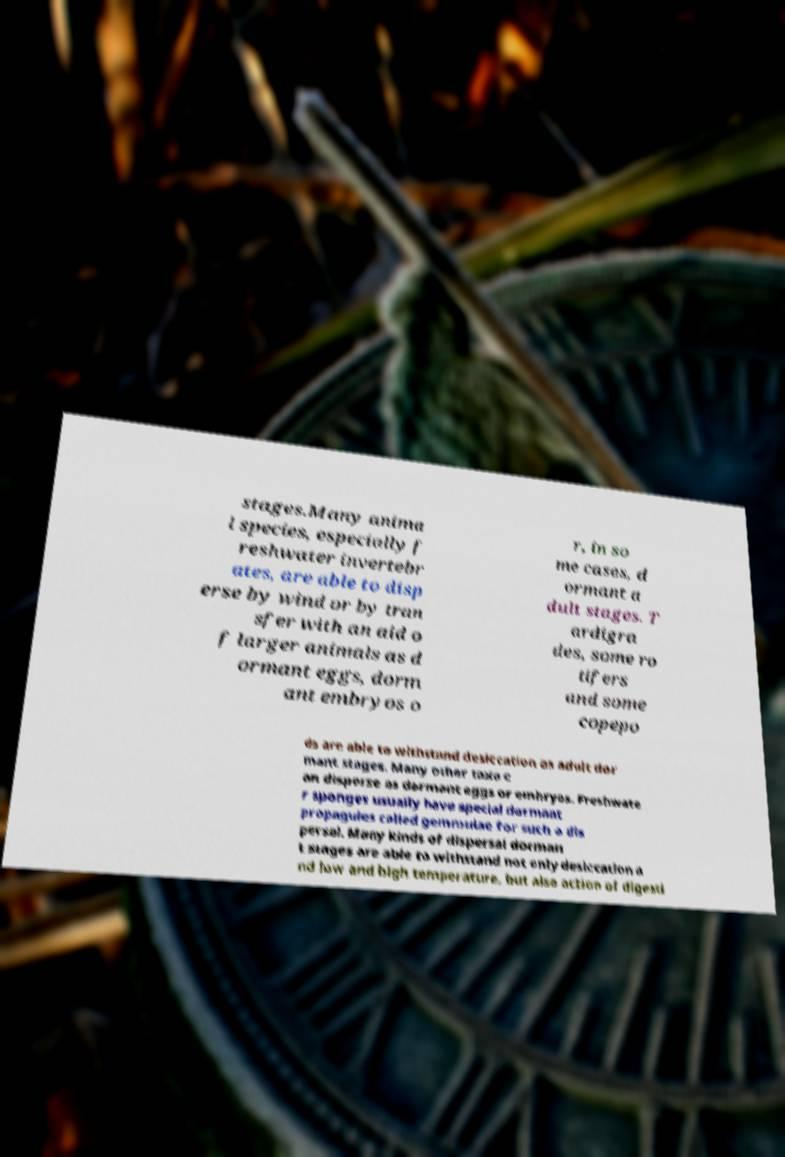I need the written content from this picture converted into text. Can you do that? stages.Many anima l species, especially f reshwater invertebr ates, are able to disp erse by wind or by tran sfer with an aid o f larger animals as d ormant eggs, dorm ant embryos o r, in so me cases, d ormant a dult stages. T ardigra des, some ro tifers and some copepo ds are able to withstand desiccation as adult dor mant stages. Many other taxa c an disperse as dormant eggs or embryos. Freshwate r sponges usually have special dormant propagules called gemmulae for such a dis persal. Many kinds of dispersal dorman t stages are able to withstand not only desiccation a nd low and high temperature, but also action of digesti 